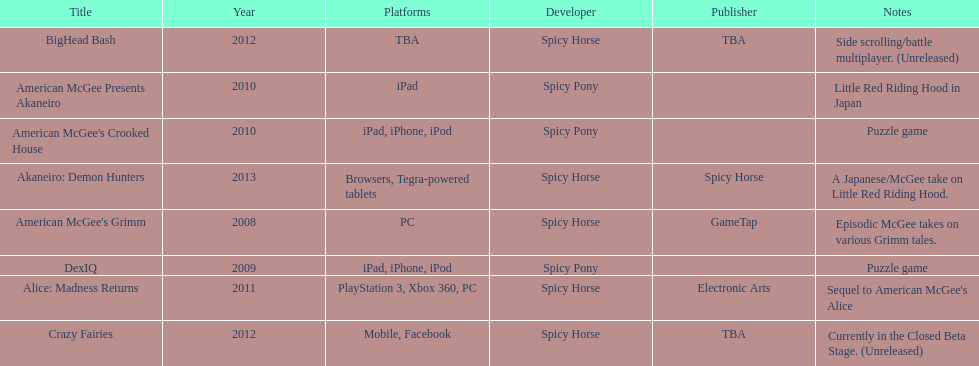What are the number of times an ipad was used as a platform? 3. 